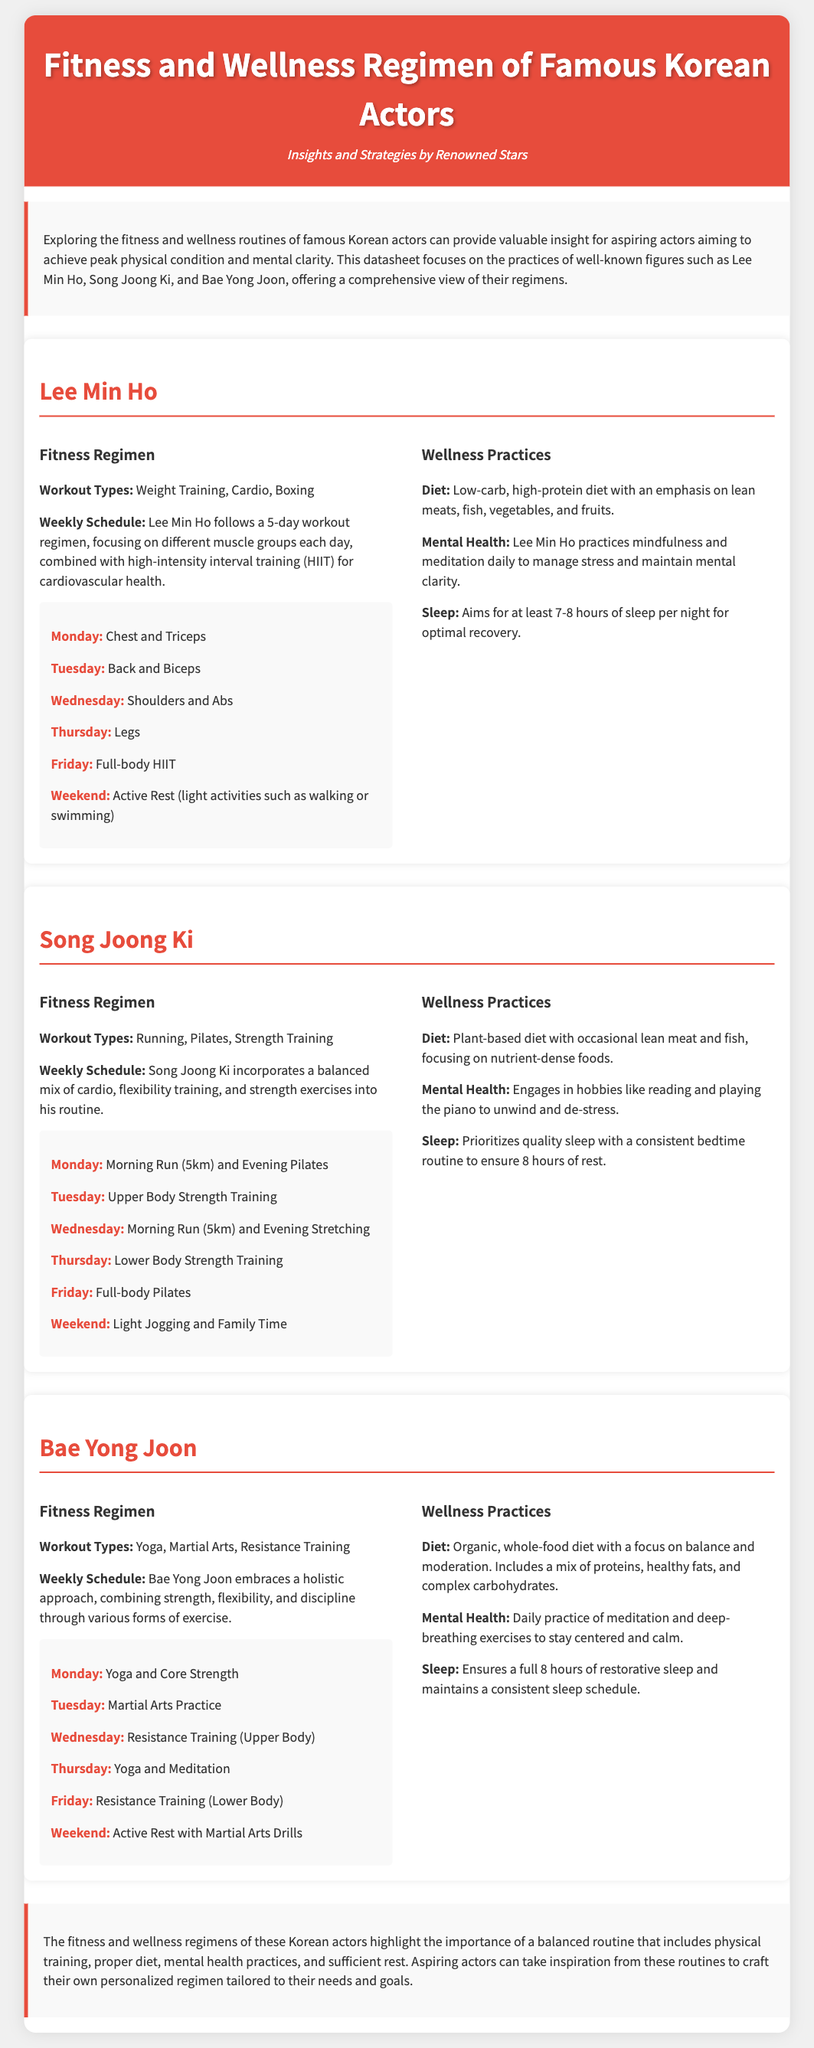What is the fitness regimen of Lee Min Ho? The fitness regimen includes weight training, cardio, and boxing.
Answer: Weight Training, Cardio, Boxing How many days a week does Lee Min Ho work out? The document states that Lee Min Ho follows a 5-day workout regimen.
Answer: 5 days What is the primary focus of Bae Yong Joon's fitness regimen? Bae Yong Joon's fitness regimen focuses on a holistic approach through various forms of exercise.
Answer: Holistic approach What type of diet does Song Joong Ki follow? Song Joong Ki follows a plant-based diet with occasional lean meat and fish.
Answer: Plant-based diet How many hours of sleep does Bae Yong Joon aim for? Bae Yong Joon aims for a full 8 hours of restorative sleep.
Answer: 8 hours What component of wellness does Lee Min Ho emphasize? Lee Min Ho emphasizes mindfulness and meditation for mental health.
Answer: Mindfulness and meditation What type of workout does Bae Yong Joon incorporate on Tuesday? On Tuesday, Bae Yong Joon incorporates martial arts practice.
Answer: Martial Arts Practice What is the main goal of the document? The main goal is to provide insights into the fitness and wellness routines of famous Korean actors.
Answer: Insights into fitness and wellness routines 